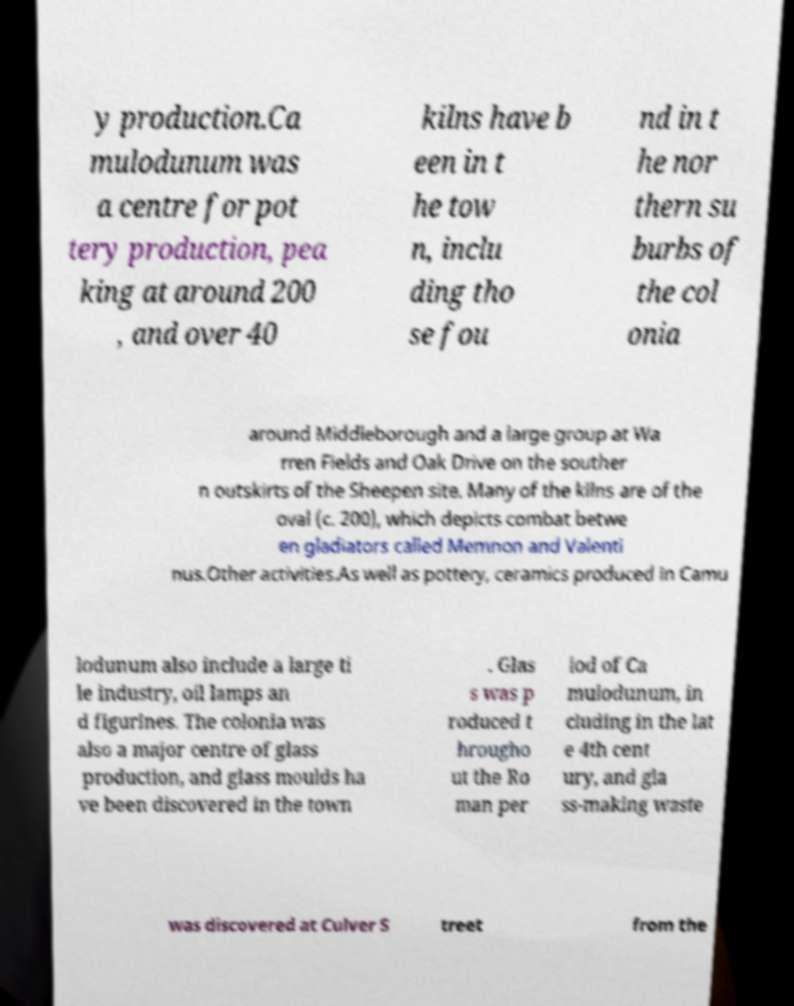Can you read and provide the text displayed in the image?This photo seems to have some interesting text. Can you extract and type it out for me? y production.Ca mulodunum was a centre for pot tery production, pea king at around 200 , and over 40 kilns have b een in t he tow n, inclu ding tho se fou nd in t he nor thern su burbs of the col onia around Middleborough and a large group at Wa rren Fields and Oak Drive on the souther n outskirts of the Sheepen site. Many of the kilns are of the oval (c. 200), which depicts combat betwe en gladiators called Memnon and Valenti nus.Other activities.As well as pottery, ceramics produced in Camu lodunum also include a large ti le industry, oil lamps an d figurines. The colonia was also a major centre of glass production, and glass moulds ha ve been discovered in the town . Glas s was p roduced t hrougho ut the Ro man per iod of Ca mulodunum, in cluding in the lat e 4th cent ury, and gla ss-making waste was discovered at Culver S treet from the 